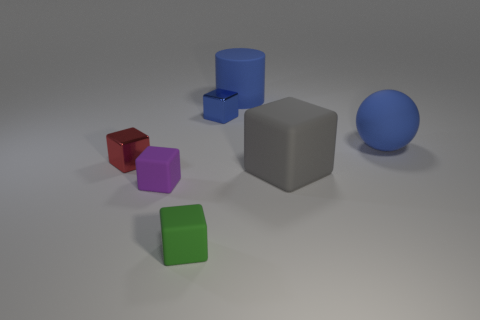What is the size of the block that is the same material as the small red thing?
Provide a succinct answer. Small. There is a big blue cylinder to the left of the blue sphere; what number of blue metallic cubes are in front of it?
Provide a succinct answer. 1. There is a big rubber block; how many blocks are on the left side of it?
Your answer should be compact. 4. There is a tiny block that is behind the small cube that is to the left of the rubber object left of the green block; what is its color?
Ensure brevity in your answer.  Blue. Is the color of the tiny shiny cube to the right of the tiny green rubber object the same as the big rubber object behind the big sphere?
Provide a succinct answer. Yes. There is a big object that is in front of the big blue thing that is to the right of the blue rubber cylinder; what is its shape?
Your answer should be very brief. Cube. Is there another metallic cube that has the same size as the red metallic block?
Provide a short and direct response. Yes. How many blue objects are the same shape as the big gray object?
Offer a terse response. 1. Are there an equal number of tiny green objects that are on the right side of the big gray block and blue things that are behind the purple rubber thing?
Provide a short and direct response. No. Are any blue things visible?
Offer a terse response. Yes. 